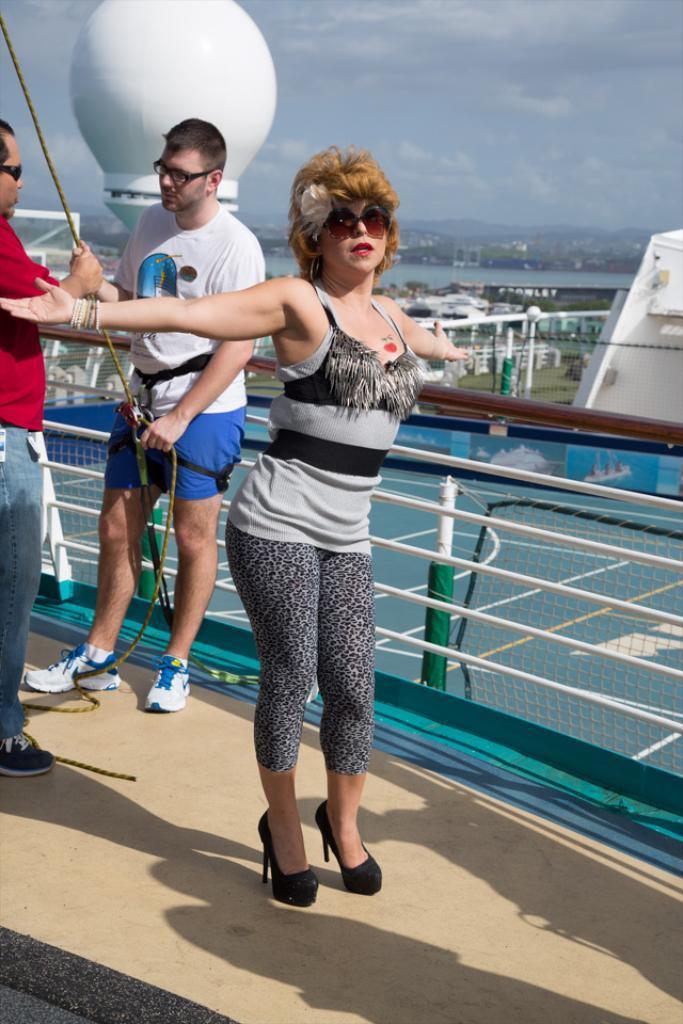Please provide a concise description of this image. In this image I can see a person standing and wearing goggles. There are 2 people on the left. There are ropes and fence. There are buildings and water at the back and there is sky at the top. 